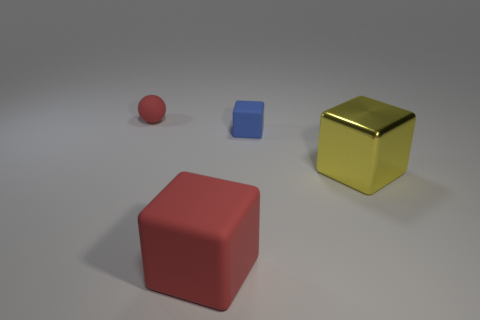Are there more tiny matte spheres than tiny blue metallic cylinders?
Ensure brevity in your answer.  Yes. There is a big shiny object; is it the same color as the rubber block in front of the tiny blue rubber object?
Your answer should be very brief. No. The matte thing that is both left of the tiny blue matte object and in front of the small red rubber object is what color?
Provide a succinct answer. Red. How many other things are there of the same material as the large yellow object?
Keep it short and to the point. 0. Are there fewer purple metallic cylinders than yellow things?
Offer a terse response. Yes. Is the small red thing made of the same material as the big cube in front of the large yellow cube?
Make the answer very short. Yes. What shape is the large thing that is in front of the big yellow cube?
Ensure brevity in your answer.  Cube. Is there any other thing that has the same color as the shiny thing?
Your answer should be compact. No. Are there fewer yellow objects that are left of the small red sphere than large green rubber objects?
Provide a succinct answer. No. How many red matte things are the same size as the metal cube?
Your answer should be very brief. 1. 